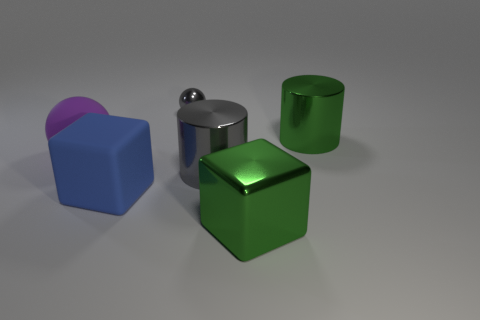The gray ball that is the same material as the big gray cylinder is what size?
Your answer should be compact. Small. Is the number of metal objects in front of the tiny sphere greater than the number of tiny gray things?
Give a very brief answer. Yes. There is a thing that is both left of the large green metallic cube and behind the big rubber sphere; what size is it?
Give a very brief answer. Small. There is another purple thing that is the same shape as the small object; what is its material?
Keep it short and to the point. Rubber. Do the cylinder that is behind the purple rubber thing and the small ball have the same size?
Offer a terse response. No. There is a large metallic thing that is on the right side of the large gray cylinder and in front of the green cylinder; what is its color?
Provide a short and direct response. Green. There is a large green shiny block on the right side of the large purple rubber ball; what number of large shiny blocks are on the right side of it?
Your response must be concise. 0. Is the shape of the small metallic object the same as the big purple matte object?
Provide a succinct answer. Yes. Are there any other things that have the same color as the large ball?
Provide a succinct answer. No. There is a small shiny thing; does it have the same shape as the large purple rubber object that is in front of the tiny thing?
Offer a terse response. Yes. 